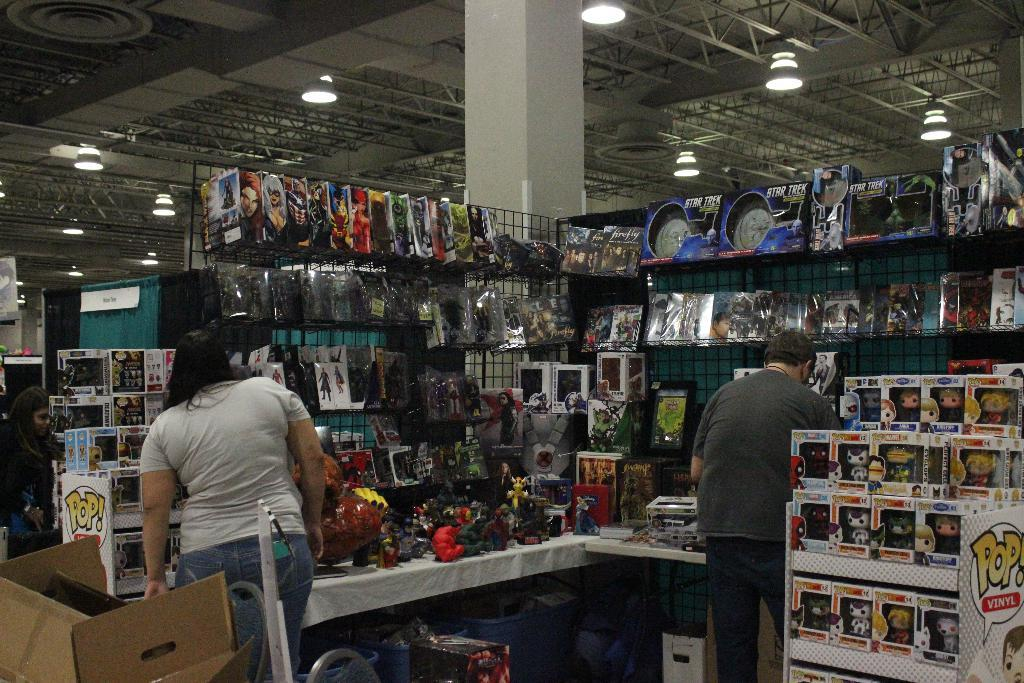Provide a one-sentence caption for the provided image. Two customers looking at products on display and a PoP collection display in the corner. 